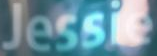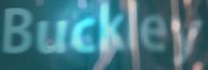Read the text from these images in sequence, separated by a semicolon. Jessie; Buckley 